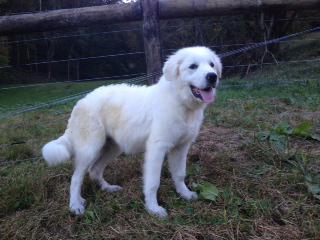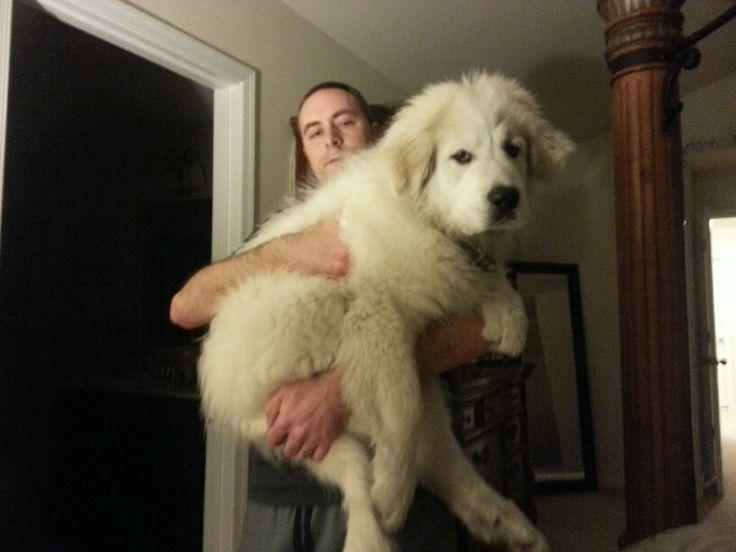The first image is the image on the left, the second image is the image on the right. Considering the images on both sides, is "There is a human holding a dog in the image on the right." valid? Answer yes or no. Yes. The first image is the image on the left, the second image is the image on the right. For the images displayed, is the sentence "A man is standing while holding a big white dog." factually correct? Answer yes or no. Yes. 